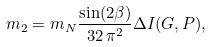Convert formula to latex. <formula><loc_0><loc_0><loc_500><loc_500>m _ { 2 } = m _ { N } \frac { \sin ( 2 \beta ) } { 3 2 \, \pi ^ { 2 } } \Delta I ( G , P ) ,</formula> 